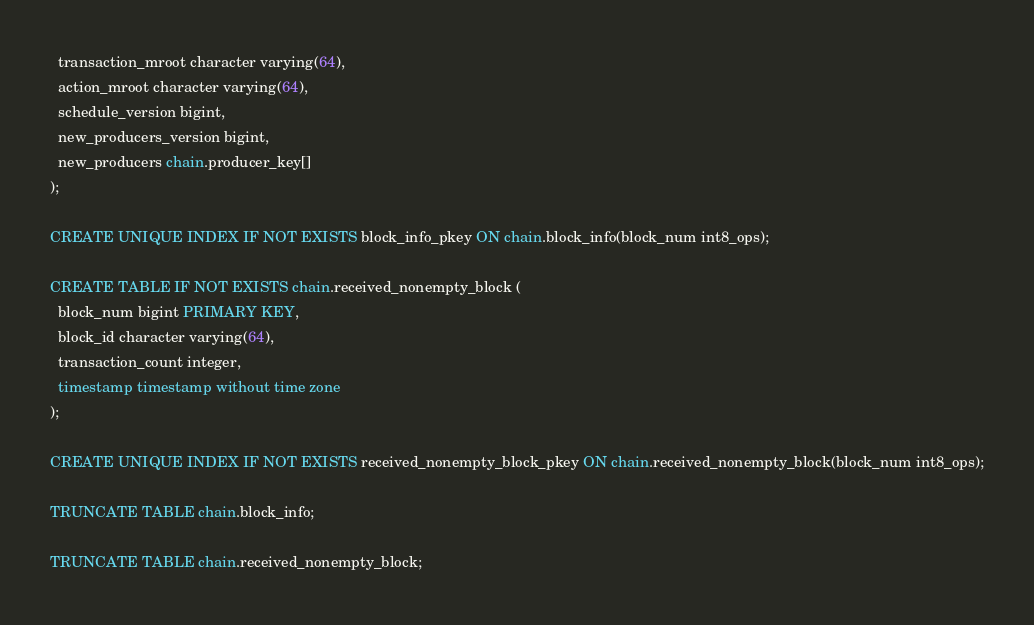Convert code to text. <code><loc_0><loc_0><loc_500><loc_500><_SQL_>  transaction_mroot character varying(64),
  action_mroot character varying(64),
  schedule_version bigint,
  new_producers_version bigint,
  new_producers chain.producer_key[]
);

CREATE UNIQUE INDEX IF NOT EXISTS block_info_pkey ON chain.block_info(block_num int8_ops);

CREATE TABLE IF NOT EXISTS chain.received_nonempty_block (
  block_num bigint PRIMARY KEY,
  block_id character varying(64),
  transaction_count integer,
  timestamp timestamp without time zone
);

CREATE UNIQUE INDEX IF NOT EXISTS received_nonempty_block_pkey ON chain.received_nonempty_block(block_num int8_ops);

TRUNCATE TABLE chain.block_info;

TRUNCATE TABLE chain.received_nonempty_block;
</code> 